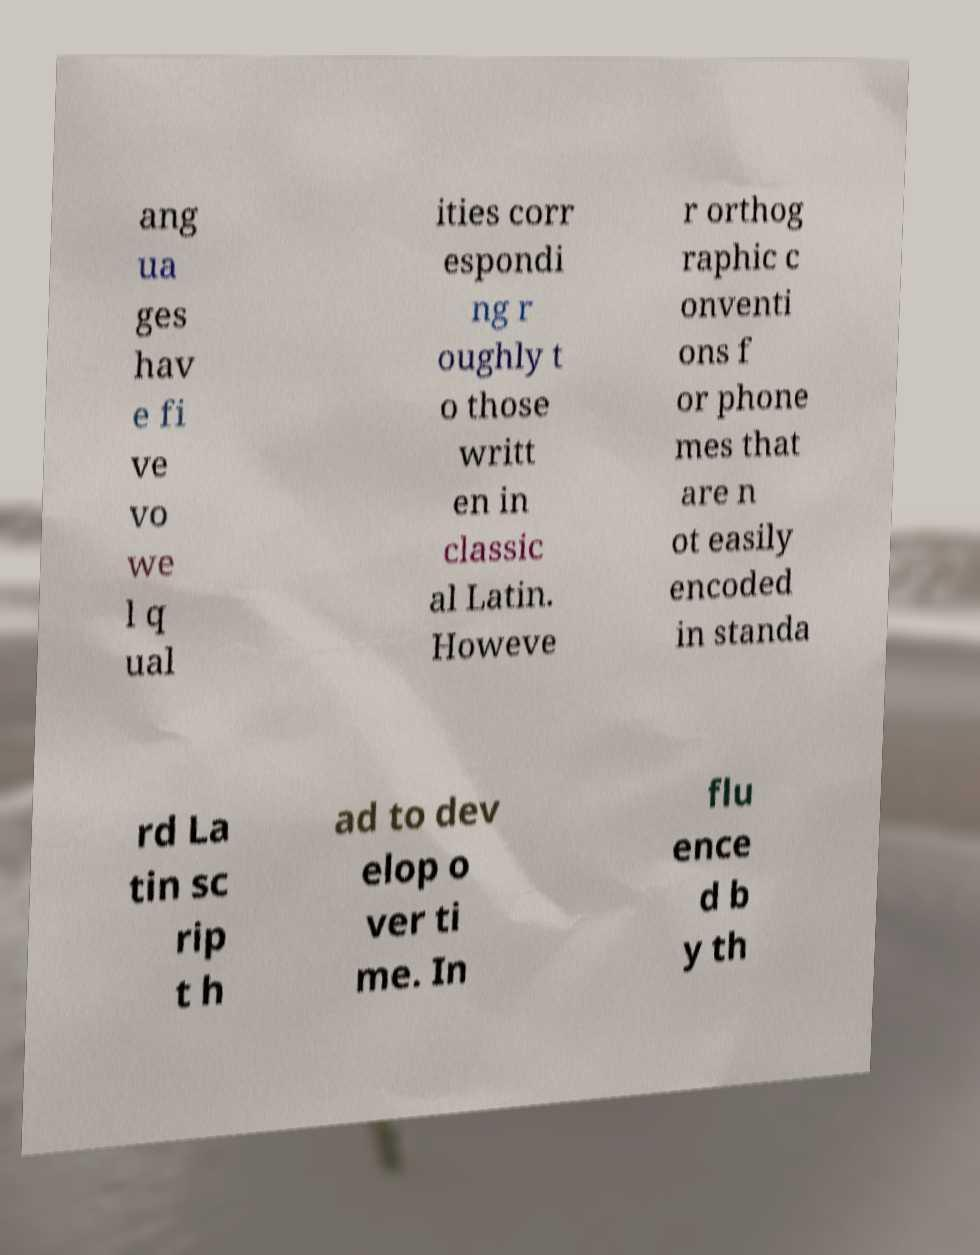For documentation purposes, I need the text within this image transcribed. Could you provide that? ang ua ges hav e fi ve vo we l q ual ities corr espondi ng r oughly t o those writt en in classic al Latin. Howeve r orthog raphic c onventi ons f or phone mes that are n ot easily encoded in standa rd La tin sc rip t h ad to dev elop o ver ti me. In flu ence d b y th 